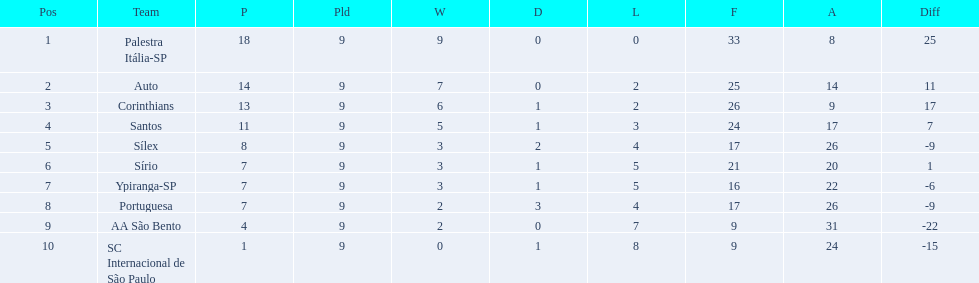How many points were scored by the teams? 18, 14, 13, 11, 8, 7, 7, 7, 4, 1. What team scored 13 points? Corinthians. 